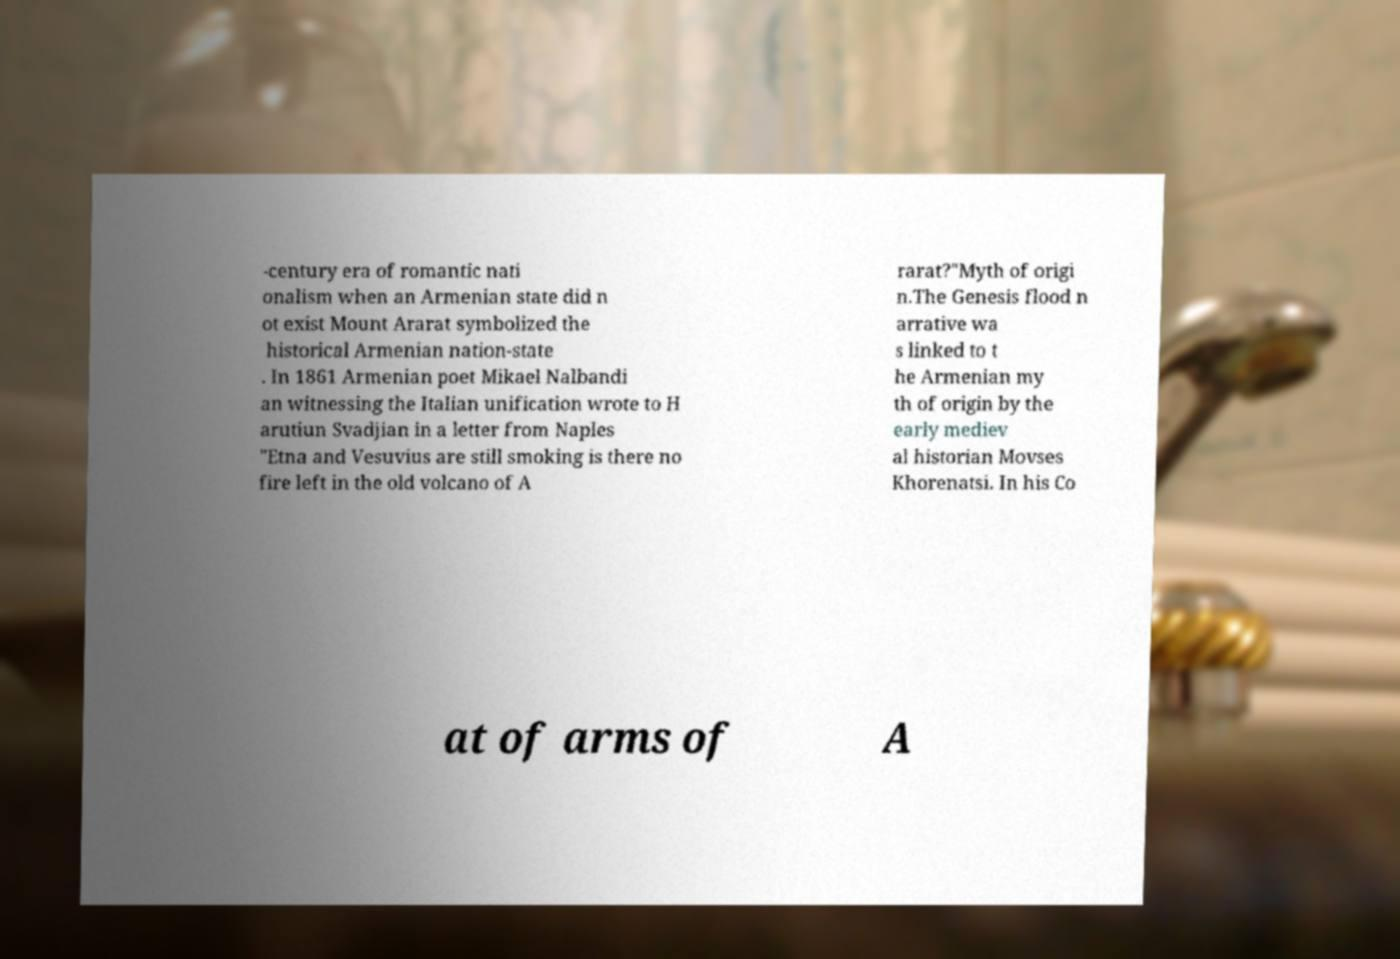Please read and relay the text visible in this image. What does it say? -century era of romantic nati onalism when an Armenian state did n ot exist Mount Ararat symbolized the historical Armenian nation-state . In 1861 Armenian poet Mikael Nalbandi an witnessing the Italian unification wrote to H arutiun Svadjian in a letter from Naples "Etna and Vesuvius are still smoking is there no fire left in the old volcano of A rarat?"Myth of origi n.The Genesis flood n arrative wa s linked to t he Armenian my th of origin by the early mediev al historian Movses Khorenatsi. In his Co at of arms of A 